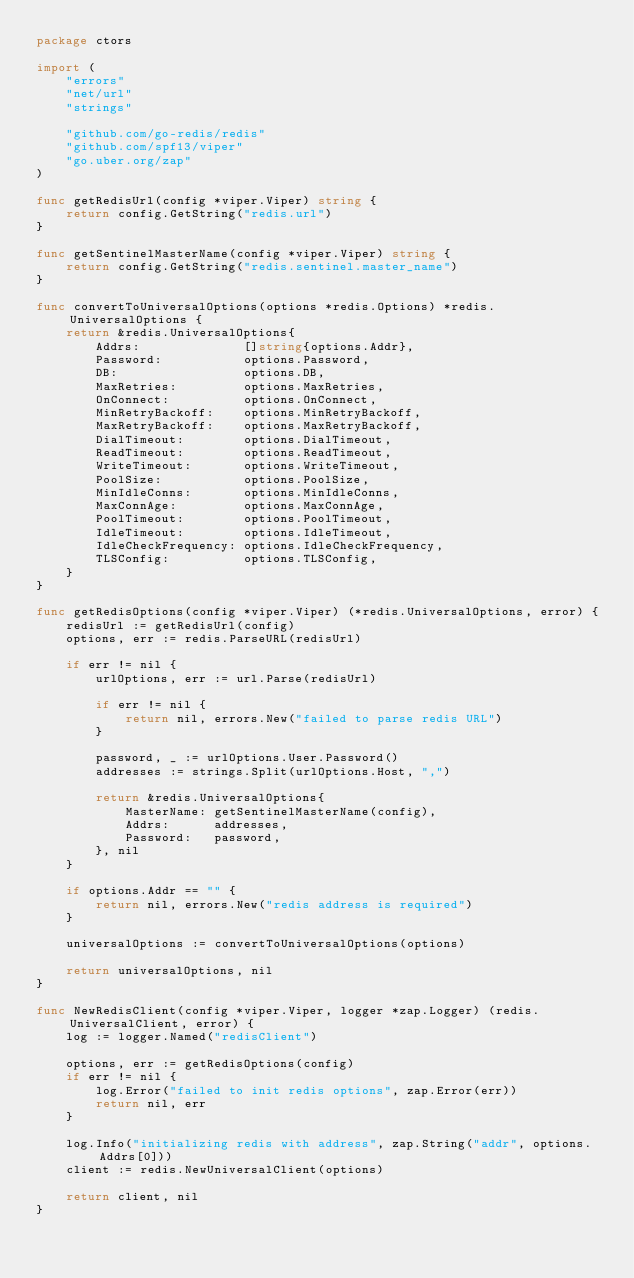Convert code to text. <code><loc_0><loc_0><loc_500><loc_500><_Go_>package ctors

import (
	"errors"
	"net/url"
	"strings"

	"github.com/go-redis/redis"
	"github.com/spf13/viper"
	"go.uber.org/zap"
)

func getRedisUrl(config *viper.Viper) string {
	return config.GetString("redis.url")
}

func getSentinelMasterName(config *viper.Viper) string {
	return config.GetString("redis.sentinel.master_name")
}

func convertToUniversalOptions(options *redis.Options) *redis.UniversalOptions {
	return &redis.UniversalOptions{
		Addrs:              []string{options.Addr},
		Password:           options.Password,
		DB:                 options.DB,
		MaxRetries:         options.MaxRetries,
		OnConnect:          options.OnConnect,
		MinRetryBackoff:    options.MinRetryBackoff,
		MaxRetryBackoff:    options.MaxRetryBackoff,
		DialTimeout:        options.DialTimeout,
		ReadTimeout:        options.ReadTimeout,
		WriteTimeout:       options.WriteTimeout,
		PoolSize:           options.PoolSize,
		MinIdleConns:       options.MinIdleConns,
		MaxConnAge:         options.MaxConnAge,
		PoolTimeout:        options.PoolTimeout,
		IdleTimeout:        options.IdleTimeout,
		IdleCheckFrequency: options.IdleCheckFrequency,
		TLSConfig:          options.TLSConfig,
	}
}

func getRedisOptions(config *viper.Viper) (*redis.UniversalOptions, error) {
	redisUrl := getRedisUrl(config)
	options, err := redis.ParseURL(redisUrl)

	if err != nil {
		urlOptions, err := url.Parse(redisUrl)

		if err != nil {
			return nil, errors.New("failed to parse redis URL")
		}

		password, _ := urlOptions.User.Password()
		addresses := strings.Split(urlOptions.Host, ",")

		return &redis.UniversalOptions{
			MasterName: getSentinelMasterName(config),
			Addrs:      addresses,
			Password:   password,
		}, nil
	}

	if options.Addr == "" {
		return nil, errors.New("redis address is required")
	}

	universalOptions := convertToUniversalOptions(options)

	return universalOptions, nil
}

func NewRedisClient(config *viper.Viper, logger *zap.Logger) (redis.UniversalClient, error) {
	log := logger.Named("redisClient")

	options, err := getRedisOptions(config)
	if err != nil {
		log.Error("failed to init redis options", zap.Error(err))
		return nil, err
	}

	log.Info("initializing redis with address", zap.String("addr", options.Addrs[0]))
	client := redis.NewUniversalClient(options)

	return client, nil
}
</code> 